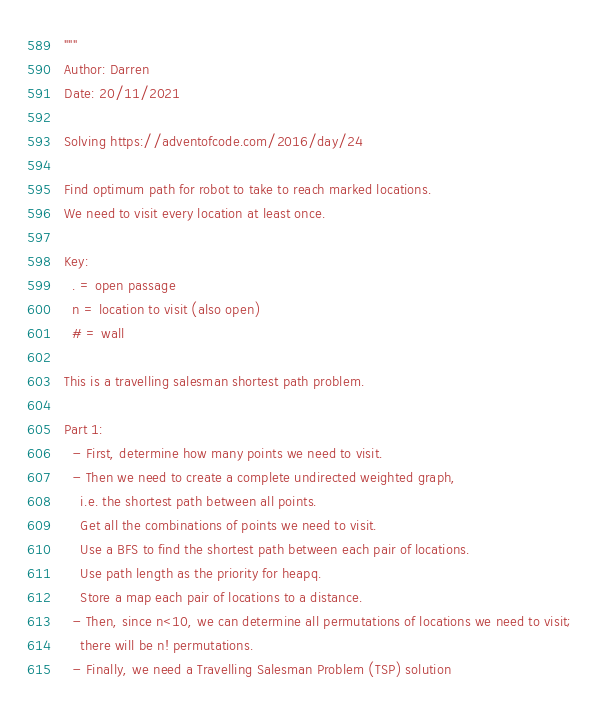Convert code to text. <code><loc_0><loc_0><loc_500><loc_500><_Python_>"""
Author: Darren
Date: 20/11/2021

Solving https://adventofcode.com/2016/day/24

Find optimum path for robot to take to reach marked locations.
We need to visit every location at least once.

Key:
  . = open passage
  n = location to visit (also open)
  # = wall
  
This is a travelling salesman shortest path problem.

Part 1:
  - First, determine how many points we need to visit.
  - Then we need to create a complete undirected weighted graph, 
    i.e. the shortest path between all points.
    Get all the combinations of points we need to visit.
    Use a BFS to find the shortest path between each pair of locations.
    Use path length as the priority for heapq.
    Store a map each pair of locations to a distance.
  - Then, since n<10, we can determine all permutations of locations we need to visit; 
    there will be n! permutations.
  - Finally, we need a Travelling Salesman Problem (TSP) solution</code> 